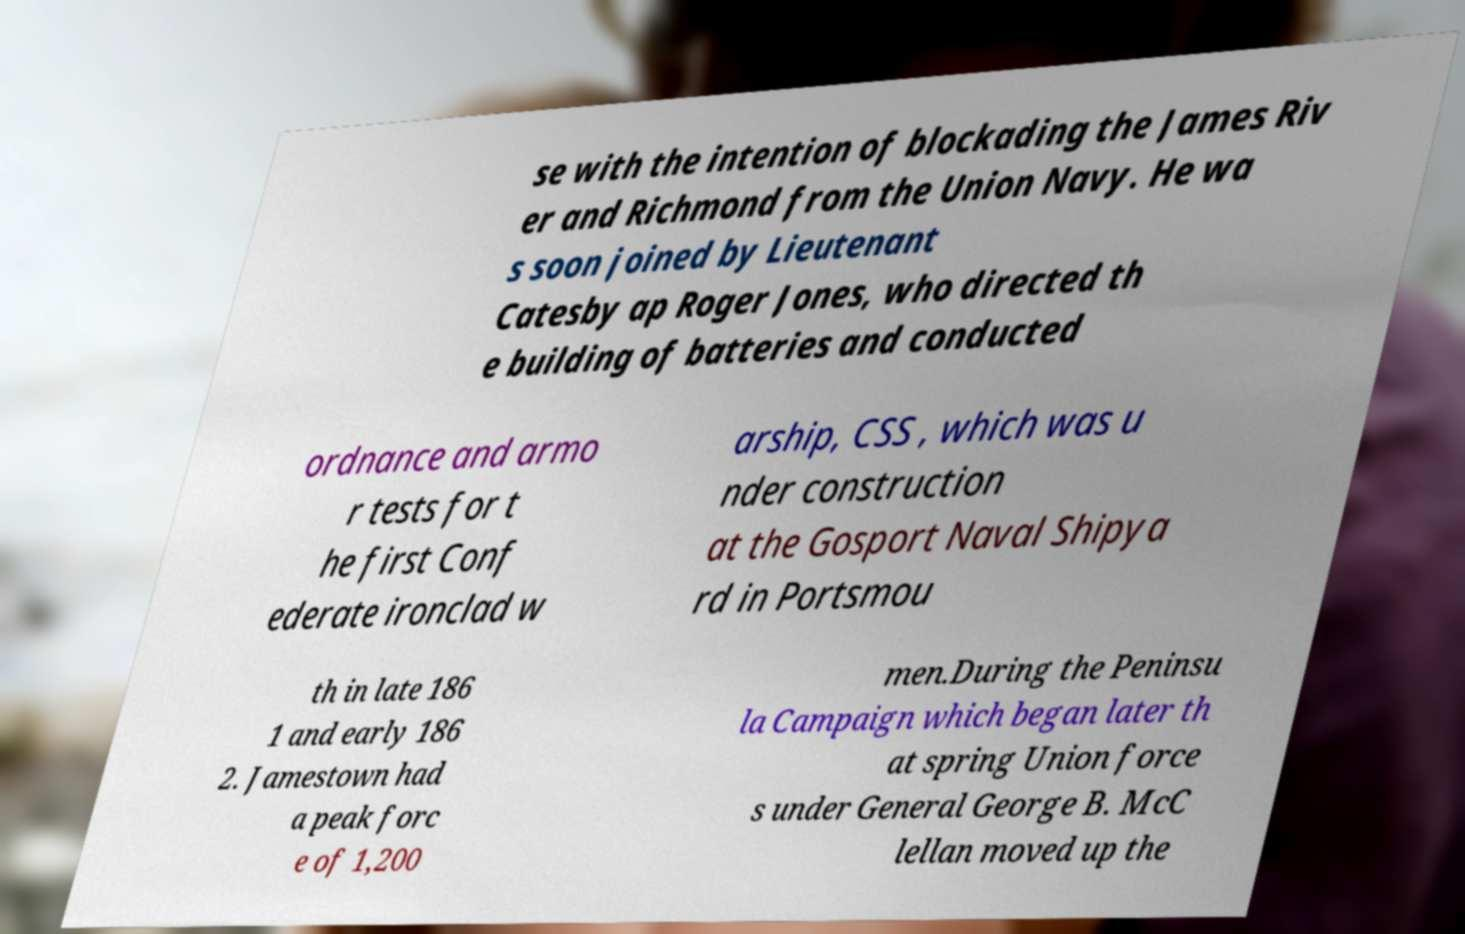There's text embedded in this image that I need extracted. Can you transcribe it verbatim? se with the intention of blockading the James Riv er and Richmond from the Union Navy. He wa s soon joined by Lieutenant Catesby ap Roger Jones, who directed th e building of batteries and conducted ordnance and armo r tests for t he first Conf ederate ironclad w arship, CSS , which was u nder construction at the Gosport Naval Shipya rd in Portsmou th in late 186 1 and early 186 2. Jamestown had a peak forc e of 1,200 men.During the Peninsu la Campaign which began later th at spring Union force s under General George B. McC lellan moved up the 